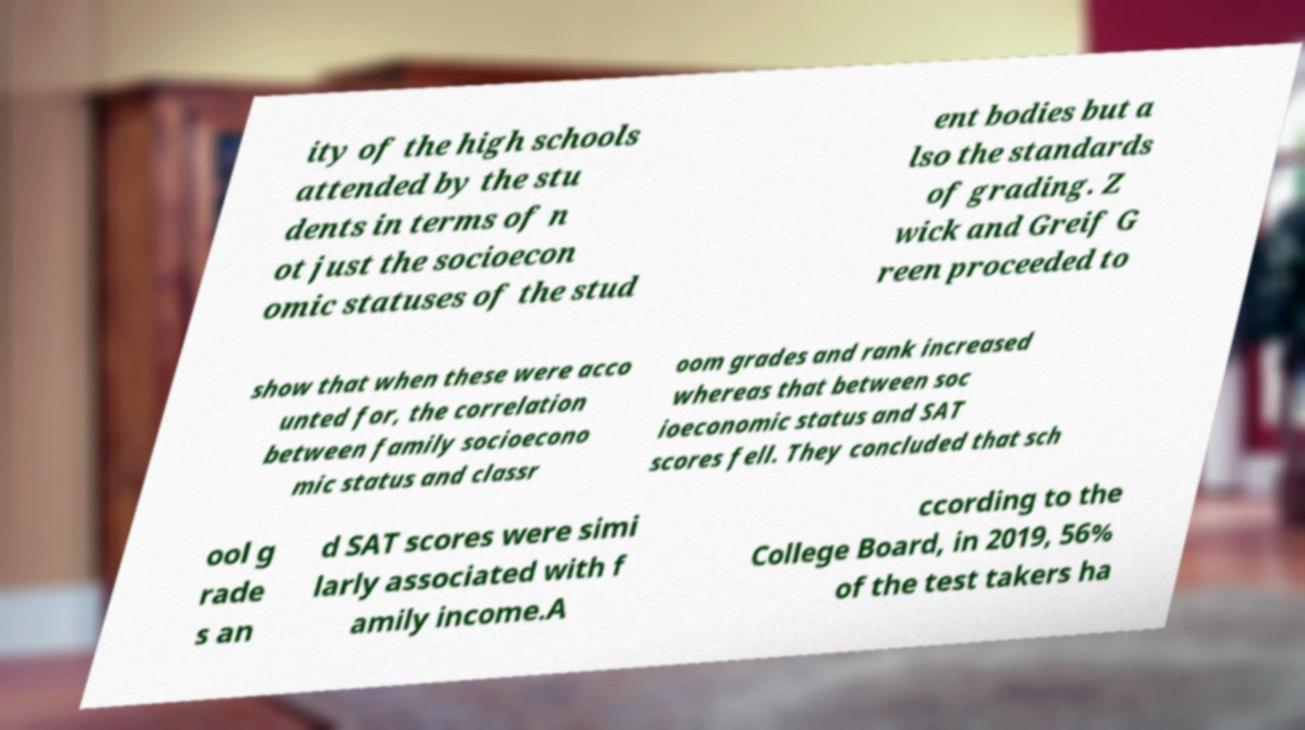There's text embedded in this image that I need extracted. Can you transcribe it verbatim? ity of the high schools attended by the stu dents in terms of n ot just the socioecon omic statuses of the stud ent bodies but a lso the standards of grading. Z wick and Greif G reen proceeded to show that when these were acco unted for, the correlation between family socioecono mic status and classr oom grades and rank increased whereas that between soc ioeconomic status and SAT scores fell. They concluded that sch ool g rade s an d SAT scores were simi larly associated with f amily income.A ccording to the College Board, in 2019, 56% of the test takers ha 